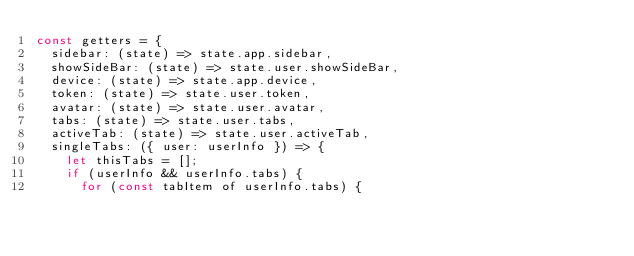Convert code to text. <code><loc_0><loc_0><loc_500><loc_500><_JavaScript_>const getters = {
  sidebar: (state) => state.app.sidebar,
  showSideBar: (state) => state.user.showSideBar,
  device: (state) => state.app.device,
  token: (state) => state.user.token,
  avatar: (state) => state.user.avatar,
  tabs: (state) => state.user.tabs,
  activeTab: (state) => state.user.activeTab,
  singleTabs: ({ user: userInfo }) => {
    let thisTabs = [];
    if (userInfo && userInfo.tabs) {
      for (const tabItem of userInfo.tabs) {</code> 